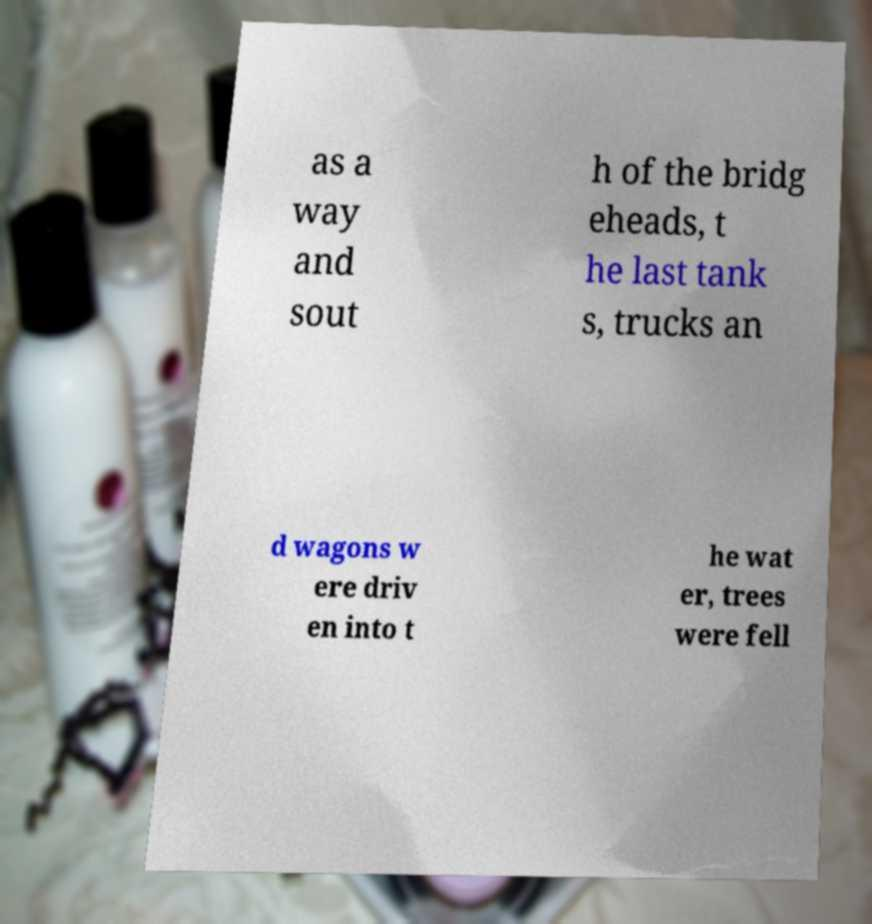For documentation purposes, I need the text within this image transcribed. Could you provide that? as a way and sout h of the bridg eheads, t he last tank s, trucks an d wagons w ere driv en into t he wat er, trees were fell 